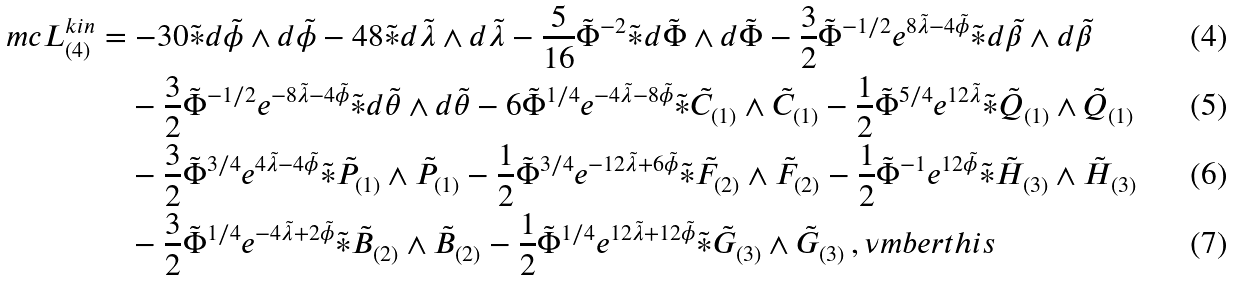Convert formula to latex. <formula><loc_0><loc_0><loc_500><loc_500>\ m c { L } ^ { k i n } _ { ( 4 ) } & = - 3 0 \tilde { \ast } d \tilde { \phi } \wedge d \tilde { \phi } - 4 8 \tilde { \ast } d \tilde { \lambda } \wedge d \tilde { \lambda } - \frac { 5 } { 1 6 } \tilde { \Phi } ^ { - 2 } \tilde { \ast } d \tilde { \Phi } \wedge d \tilde { \Phi } - \frac { 3 } { 2 } \tilde { \Phi } ^ { - 1 / 2 } e ^ { 8 \tilde { \lambda } - 4 \tilde { \phi } } \tilde { \ast } d \tilde { \beta } \wedge d \tilde { \beta } \\ & \quad - \frac { 3 } { 2 } \tilde { \Phi } ^ { - 1 / 2 } e ^ { - 8 \tilde { \lambda } - 4 \tilde { \phi } } \tilde { \ast } d \tilde { \theta } \wedge d \tilde { \theta } - 6 \tilde { \Phi } ^ { 1 / 4 } e ^ { - 4 \tilde { \lambda } - 8 \tilde { \phi } } \tilde { \ast } \tilde { C } _ { ( 1 ) } \wedge \tilde { C } _ { ( 1 ) } - \frac { 1 } { 2 } \tilde { \Phi } ^ { 5 / 4 } e ^ { 1 2 \tilde { \lambda } } \tilde { \ast } \tilde { Q } _ { ( 1 ) } \wedge \tilde { Q } _ { ( 1 ) } \\ & \quad - \frac { 3 } { 2 } \tilde { \Phi } ^ { 3 / 4 } e ^ { 4 \tilde { \lambda } - 4 \tilde { \phi } } \tilde { \ast } \tilde { P } _ { ( 1 ) } \wedge \tilde { P } _ { ( 1 ) } - \frac { 1 } { 2 } \tilde { \Phi } ^ { 3 / 4 } e ^ { - 1 2 \tilde { \lambda } + 6 \tilde { \phi } } \tilde { \ast } \tilde { F } _ { ( 2 ) } \wedge \tilde { F } _ { ( 2 ) } - \frac { 1 } { 2 } \tilde { \Phi } ^ { - 1 } e ^ { 1 2 \tilde { \phi } } \tilde { \ast } \tilde { H } _ { ( 3 ) } \wedge \tilde { H } _ { ( 3 ) } \\ & \quad - \frac { 3 } { 2 } \tilde { \Phi } ^ { 1 / 4 } e ^ { - 4 \tilde { \lambda } + 2 \tilde { \phi } } \tilde { \ast } \tilde { B } _ { ( 2 ) } \wedge \tilde { B } _ { ( 2 ) } - \frac { 1 } { 2 } \tilde { \Phi } ^ { 1 / 4 } e ^ { 1 2 \tilde { \lambda } + 1 2 \tilde { \phi } } \tilde { \ast } \tilde { G } _ { ( 3 ) } \wedge \tilde { G } _ { ( 3 ) } \, , \nu m b e r t h i s</formula> 